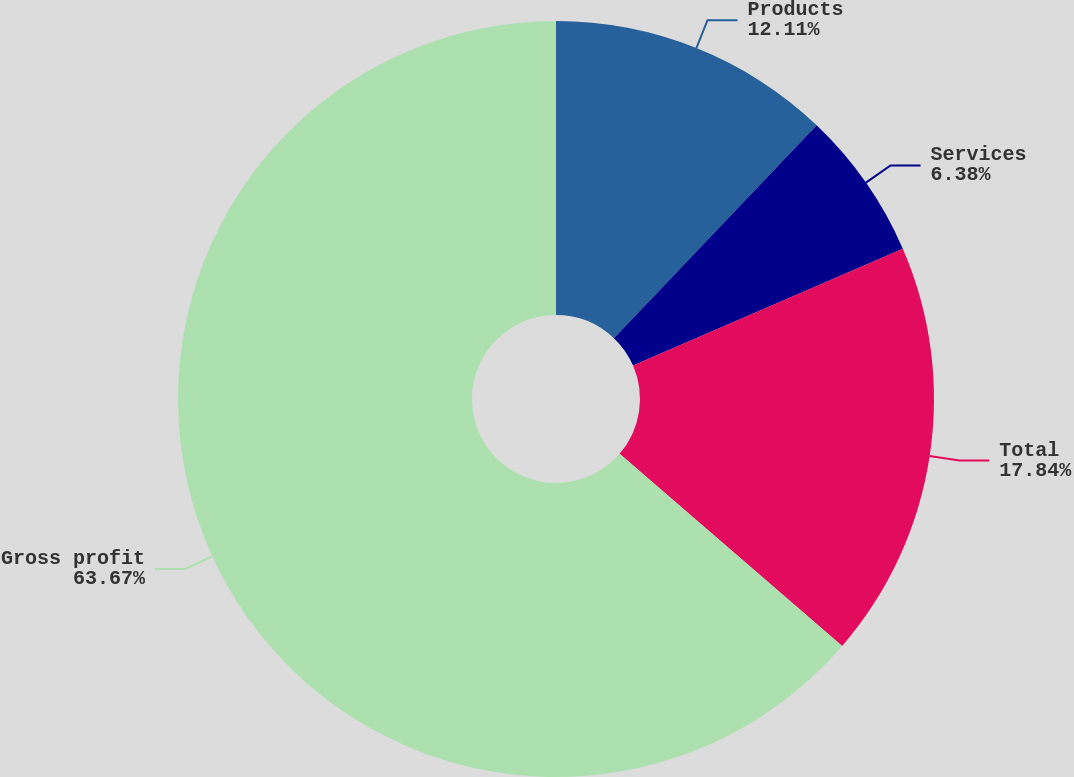<chart> <loc_0><loc_0><loc_500><loc_500><pie_chart><fcel>Products<fcel>Services<fcel>Total<fcel>Gross profit<nl><fcel>12.11%<fcel>6.38%<fcel>17.84%<fcel>63.67%<nl></chart> 